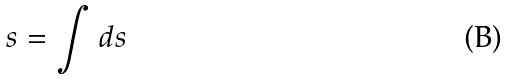<formula> <loc_0><loc_0><loc_500><loc_500>s = \int d s</formula> 